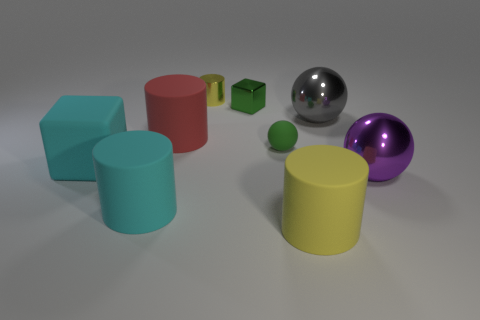What is the material of the other small object that is the same shape as the purple metallic thing?
Provide a short and direct response. Rubber. What number of things are things that are to the right of the large gray object or cylinders that are in front of the tiny green metal block?
Your response must be concise. 4. There is a shiny block; does it have the same color as the big cylinder on the right side of the small metallic cylinder?
Give a very brief answer. No. What shape is the red object that is made of the same material as the big block?
Give a very brief answer. Cylinder. What number of big yellow cylinders are there?
Your answer should be compact. 1. How many objects are blocks that are in front of the big gray metallic object or big blue metal cubes?
Keep it short and to the point. 1. Does the ball that is to the left of the yellow rubber cylinder have the same color as the rubber block?
Offer a terse response. No. How many other objects are there of the same color as the metallic cube?
Keep it short and to the point. 1. How many tiny things are green metallic cubes or purple metal cylinders?
Your answer should be very brief. 1. Are there more small cyan objects than tiny green matte things?
Provide a succinct answer. No. 